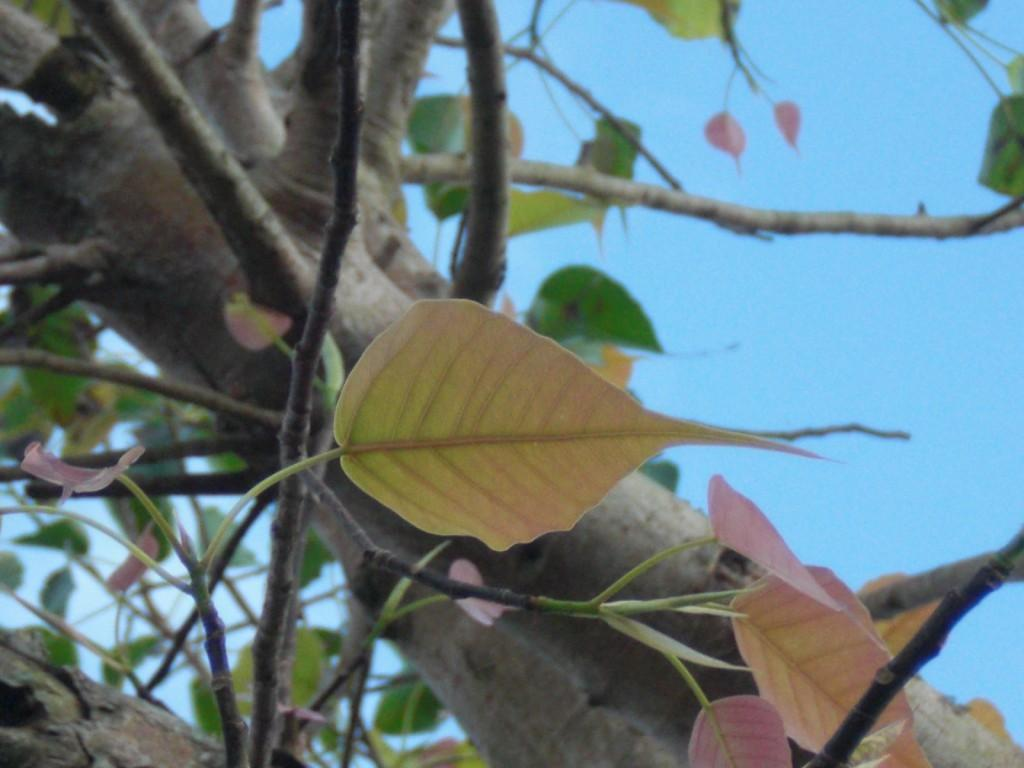What is the main subject in the center of the image? There is a tree in the center of the image. What can be seen in the background of the image? The sky is visible in the background of the image. What type of breakfast is being served on the tree in the image? There is no breakfast present in the image; it features a tree and the sky. What type of flesh can be seen hanging from the branches of the tree in the image? There is no flesh present in the image; it features a tree and the sky. 